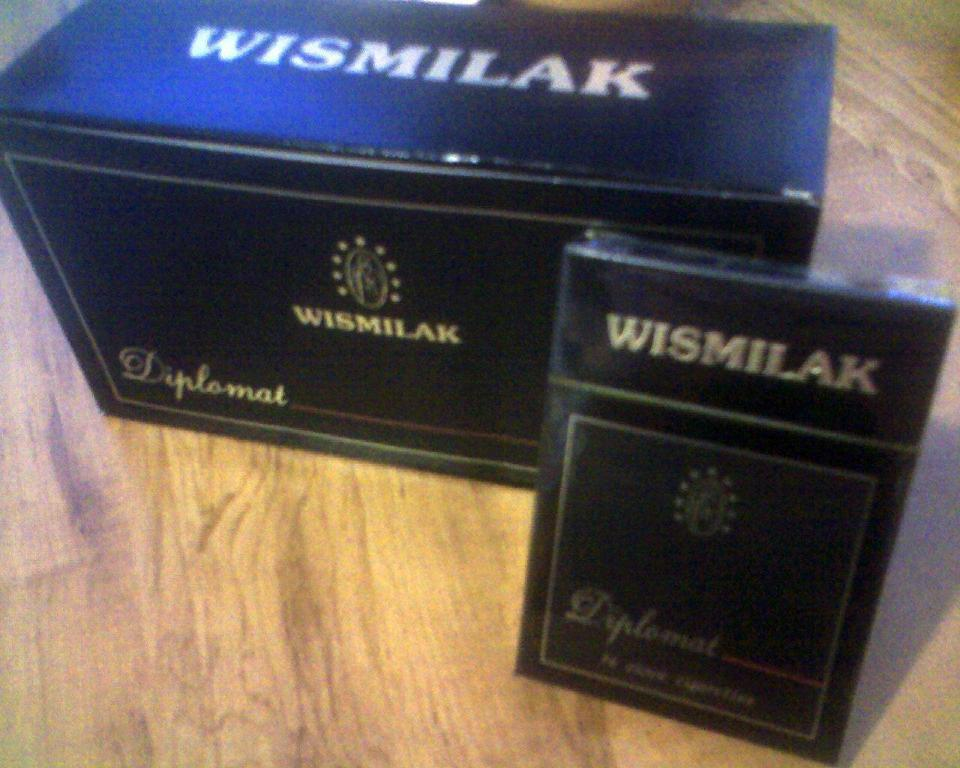Provide a one-sentence caption for the provided image. The brand of the black box is Wismilak. 